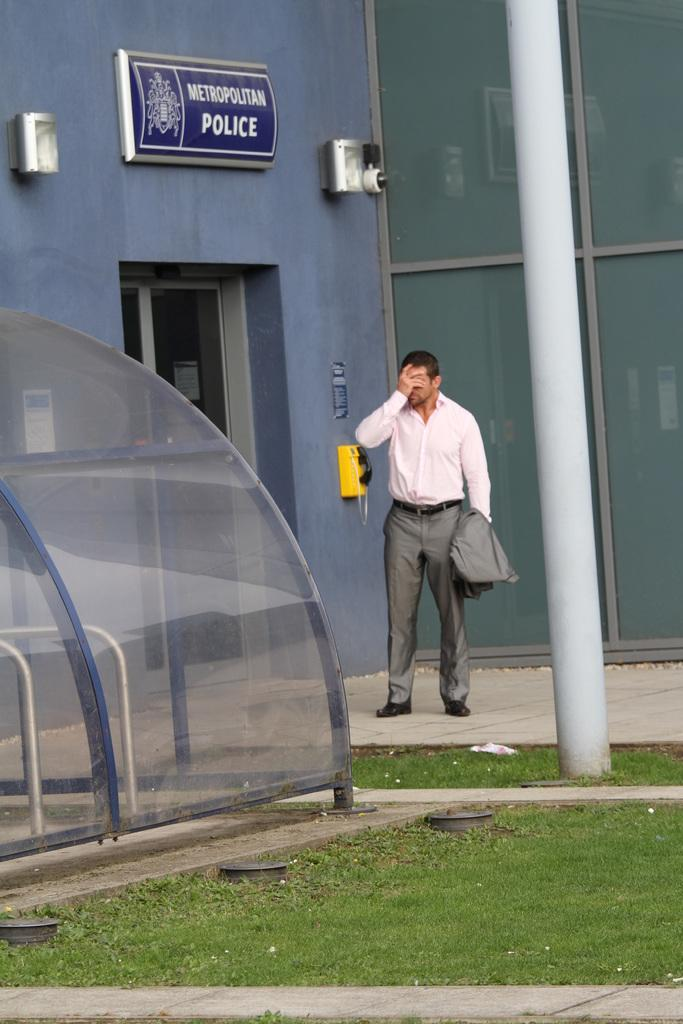What type of vegetation is present in the image? There is grass in the image. What type of structure is visible in the image? There is a building in the image. What additional object can be seen in the image? There is a poster in the image. Can you describe the person in the image? There is a man standing in the image, and he is wearing a white color shirt. What communication device is present in the image? There is a telephone in the image. Is the writer using a brick to prop up the umbrella in the image? There is no writer, umbrella, or brick present in the image. 